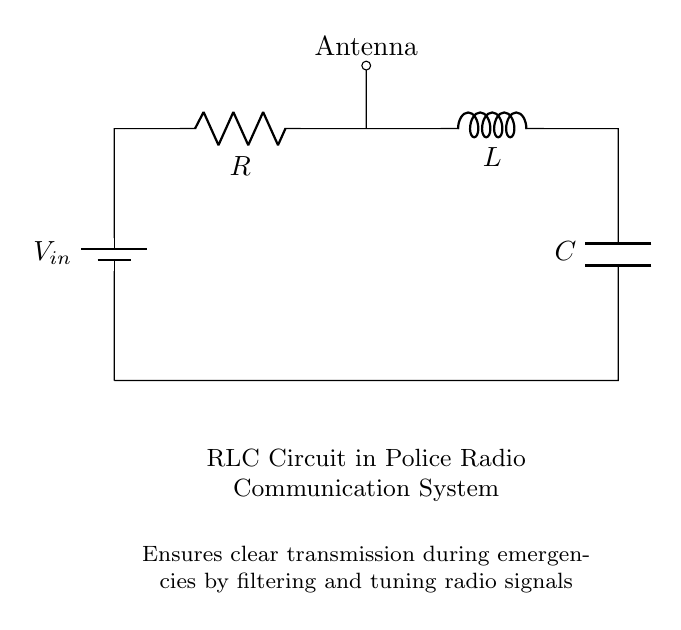What is the power source in this circuit? The power source is a battery, indicated as V in the circuit diagram. It provides the necessary voltage for the circuit operation.
Answer: battery What components are present in this RLC circuit? The components present are a resistor, inductor, and capacitor, which are labeled as R, L, and C respectively in the diagram.
Answer: resistor, inductor, capacitor What is the purpose of the antenna in the circuit? The antenna is used to send or receive radio signals, indicated by the connection at point A. It plays a crucial role in radio communication for relaying emergency messages.
Answer: sends or receives radio signals How does this RLC circuit enhance communication during emergencies? This RLC circuit filters and tunes radio signals, improving the clarity of transmission, which is essential during emergency situations. This is indicated in the circuit's description.
Answer: filters and tunes signals What would happen if the capacitor were removed from this circuit? Removing the capacitor would disrupt the tuning and filtering ability of the circuit, potentially leading to poor signal clarity and higher noise levels. The capacitor is crucial for maintaining proper signal quality.
Answer: disrupt tuning and filtering What type of circuit is depicted here? The circuit depicted is a resonant circuit, specifically an RLC circuit that can resonate at a particular frequency, which is vital for effective radio transmission.
Answer: resonant circuit What is the role of the resistor in this RLC circuit? The resistor limits the current flowing through the circuit and helps in controlling the quality factor and damping of the circuit, which is important for stability in radio communication.
Answer: limits current 